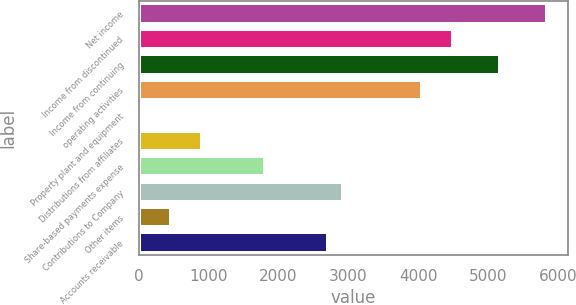Convert chart to OTSL. <chart><loc_0><loc_0><loc_500><loc_500><bar_chart><fcel>Net income<fcel>Income from discontinued<fcel>Income from continuing<fcel>operating activities<fcel>Property plant and equipment<fcel>Distributions from affiliates<fcel>Share-based payments expense<fcel>Contributions to Company<fcel>Other items<fcel>Accounts receivable<nl><fcel>5846.2<fcel>4498.3<fcel>5172.25<fcel>4049<fcel>5.3<fcel>903.9<fcel>1802.5<fcel>2925.75<fcel>454.6<fcel>2701.1<nl></chart> 